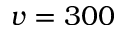<formula> <loc_0><loc_0><loc_500><loc_500>v = 3 0 0</formula> 